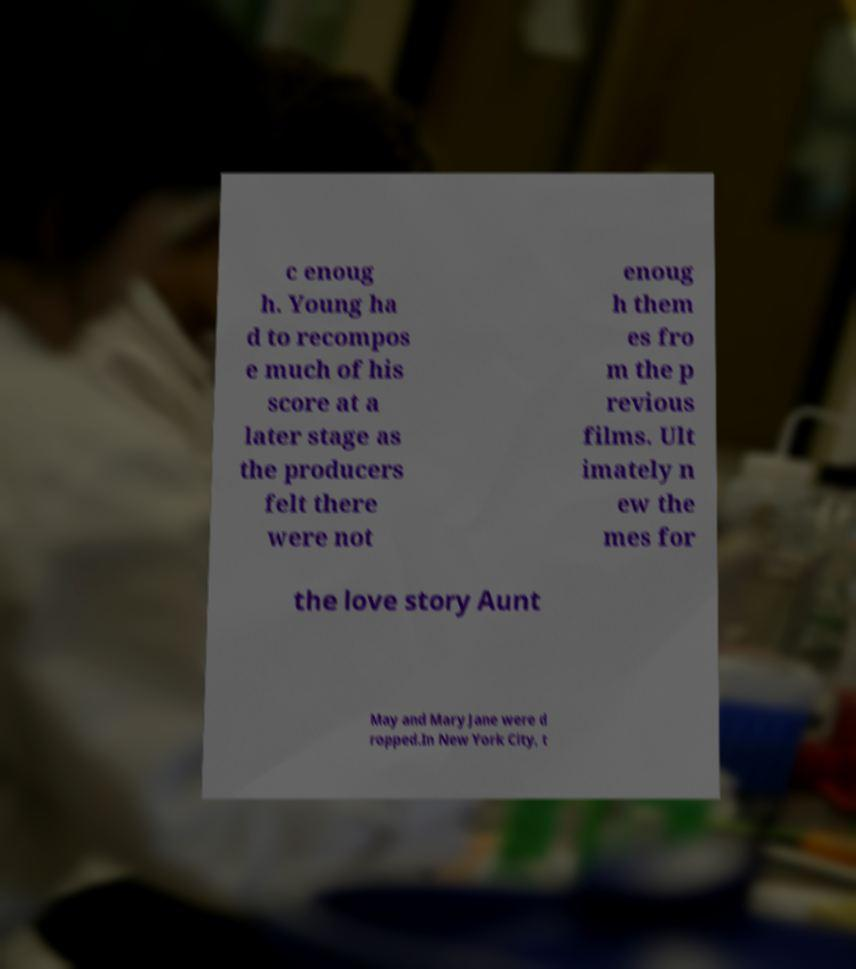What messages or text are displayed in this image? I need them in a readable, typed format. c enoug h. Young ha d to recompos e much of his score at a later stage as the producers felt there were not enoug h them es fro m the p revious films. Ult imately n ew the mes for the love story Aunt May and Mary Jane were d ropped.In New York City, t 